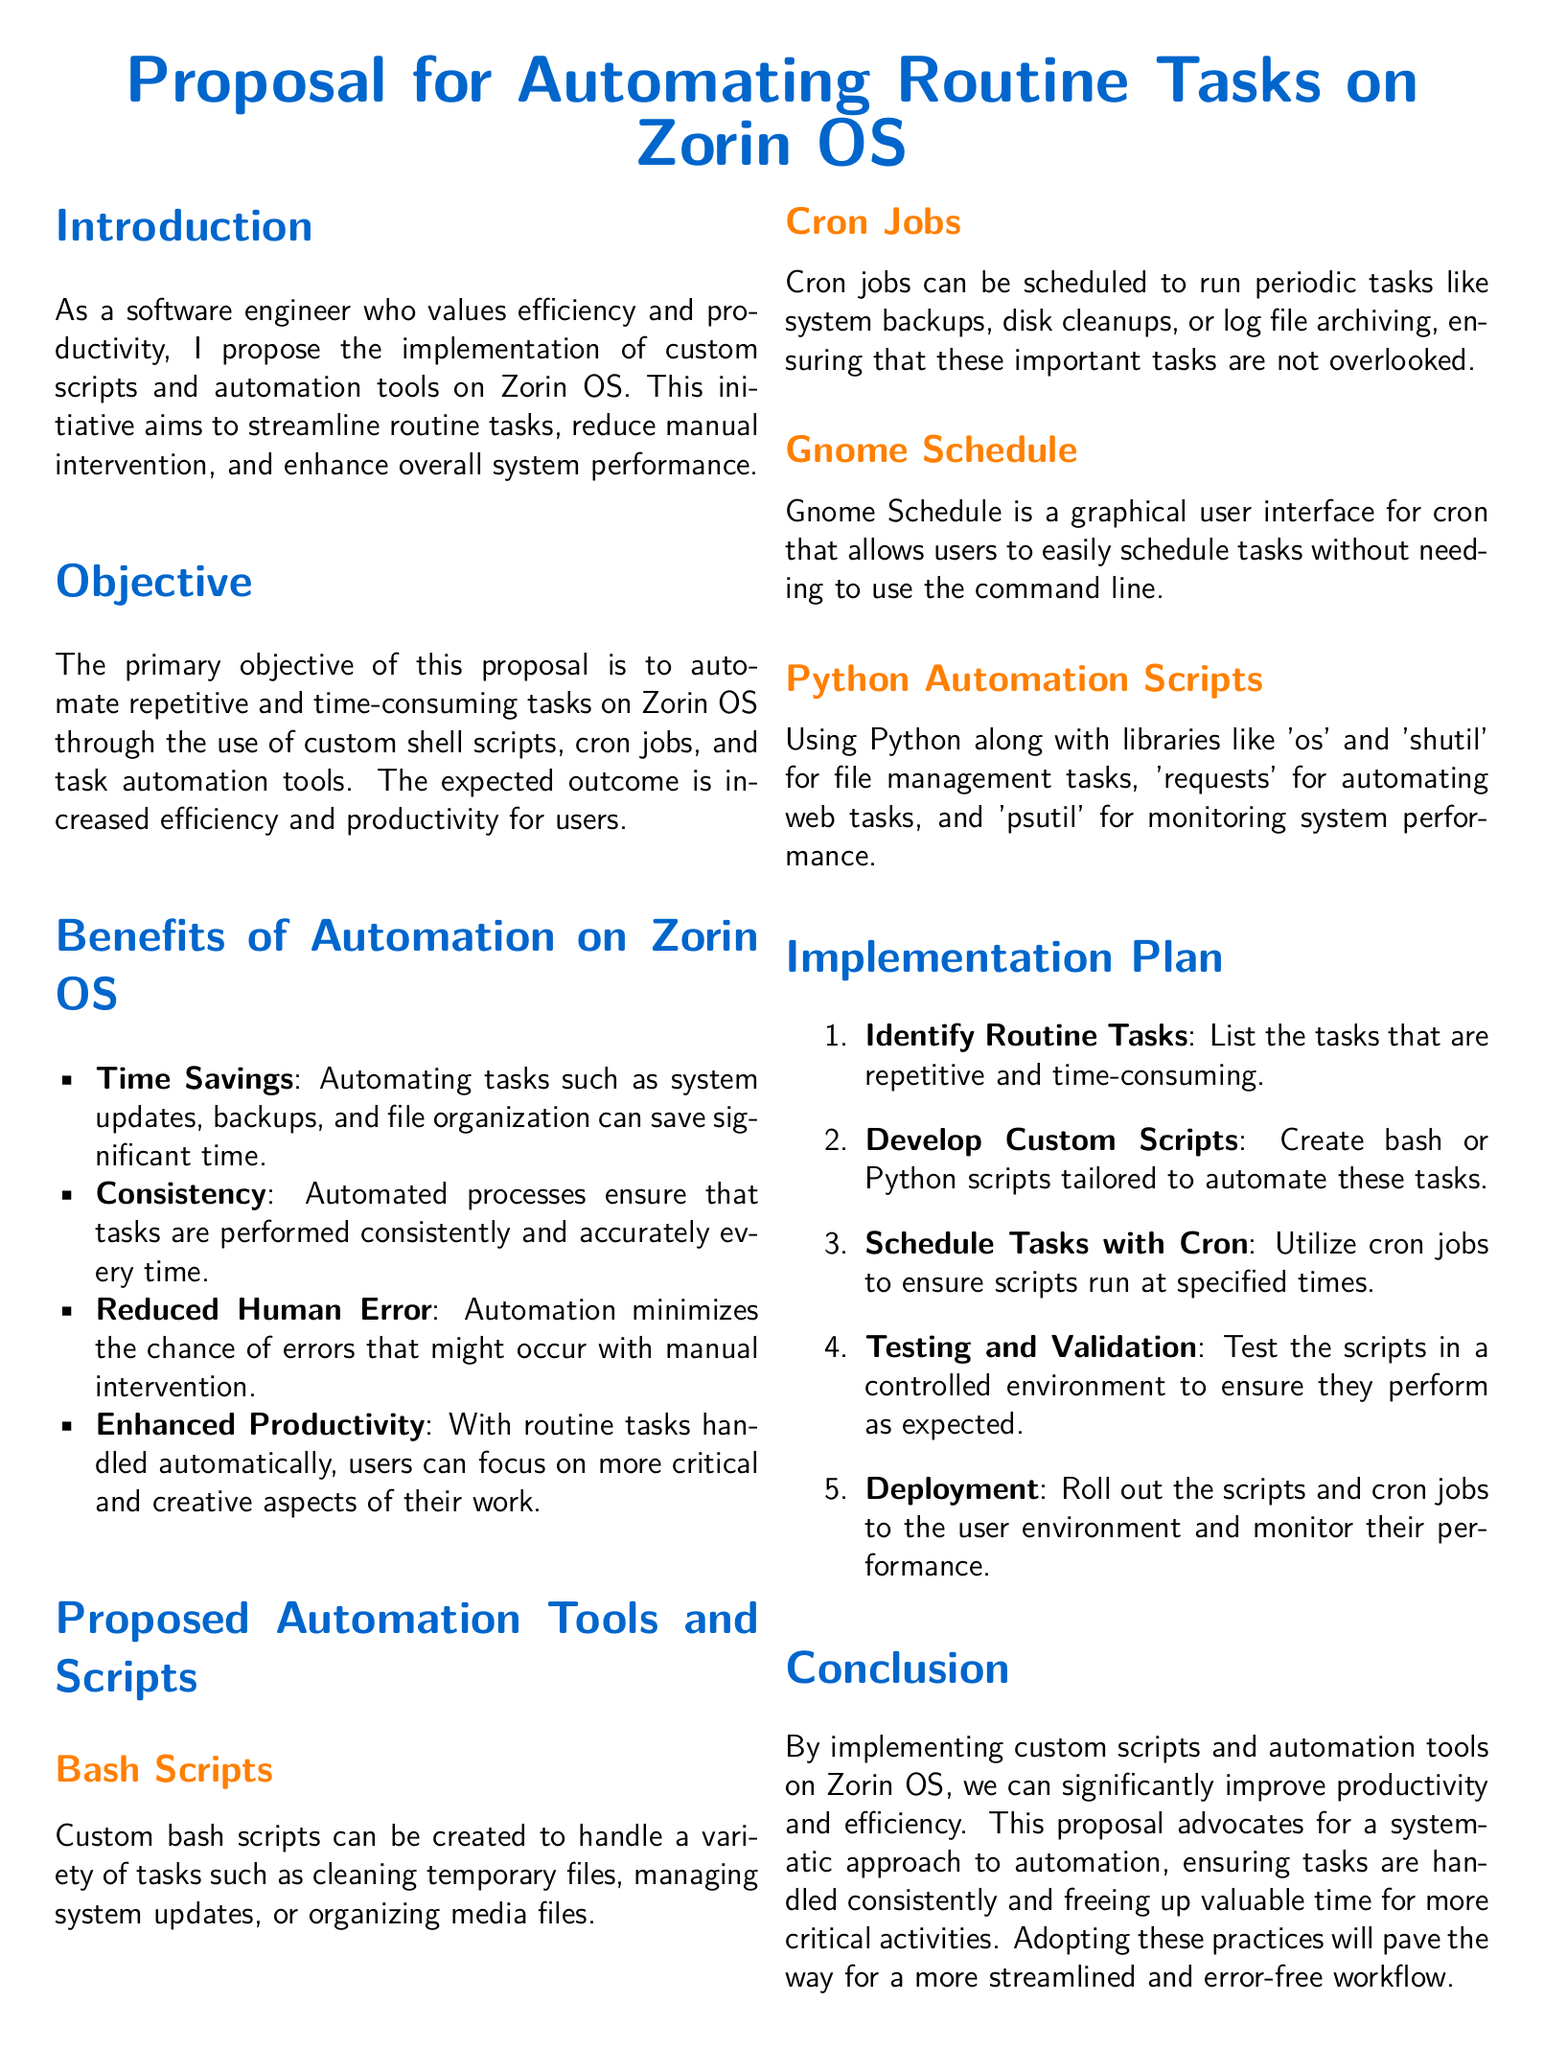What is the main focus of the proposal? The main focus of the proposal is to automate routine tasks on Zorin OS.
Answer: Automate routine tasks on Zorin OS What are two examples of automation tools mentioned in the proposal? The proposal mentions custom bash scripts and cron jobs as examples of automation tools.
Answer: Custom bash scripts and cron jobs What is the expected outcome of implementing automation? The expected outcome is increased efficiency and productivity for users.
Answer: Increased efficiency and productivity How many steps are in the implementation plan? The implementation plan consists of five steps that guide the process.
Answer: Five steps What is the primary benefit of consistency mentioned? The primary benefit of consistency is that automated processes ensure tasks are performed accurately every time.
Answer: Tasks are performed accurately Which graphical user interface is mentioned for scheduling tasks? The proposal mentions Gnome Schedule as a graphical user interface for cron.
Answer: Gnome Schedule What is the first step in the implementation plan? The first step involves identifying routine tasks that are repetitive and time-consuming.
Answer: Identify routine tasks What are Python scripts used for in the proposal? Python scripts are used for file management tasks, web tasks, and monitoring system performance.
Answer: File management tasks, web tasks, and monitoring system performance 